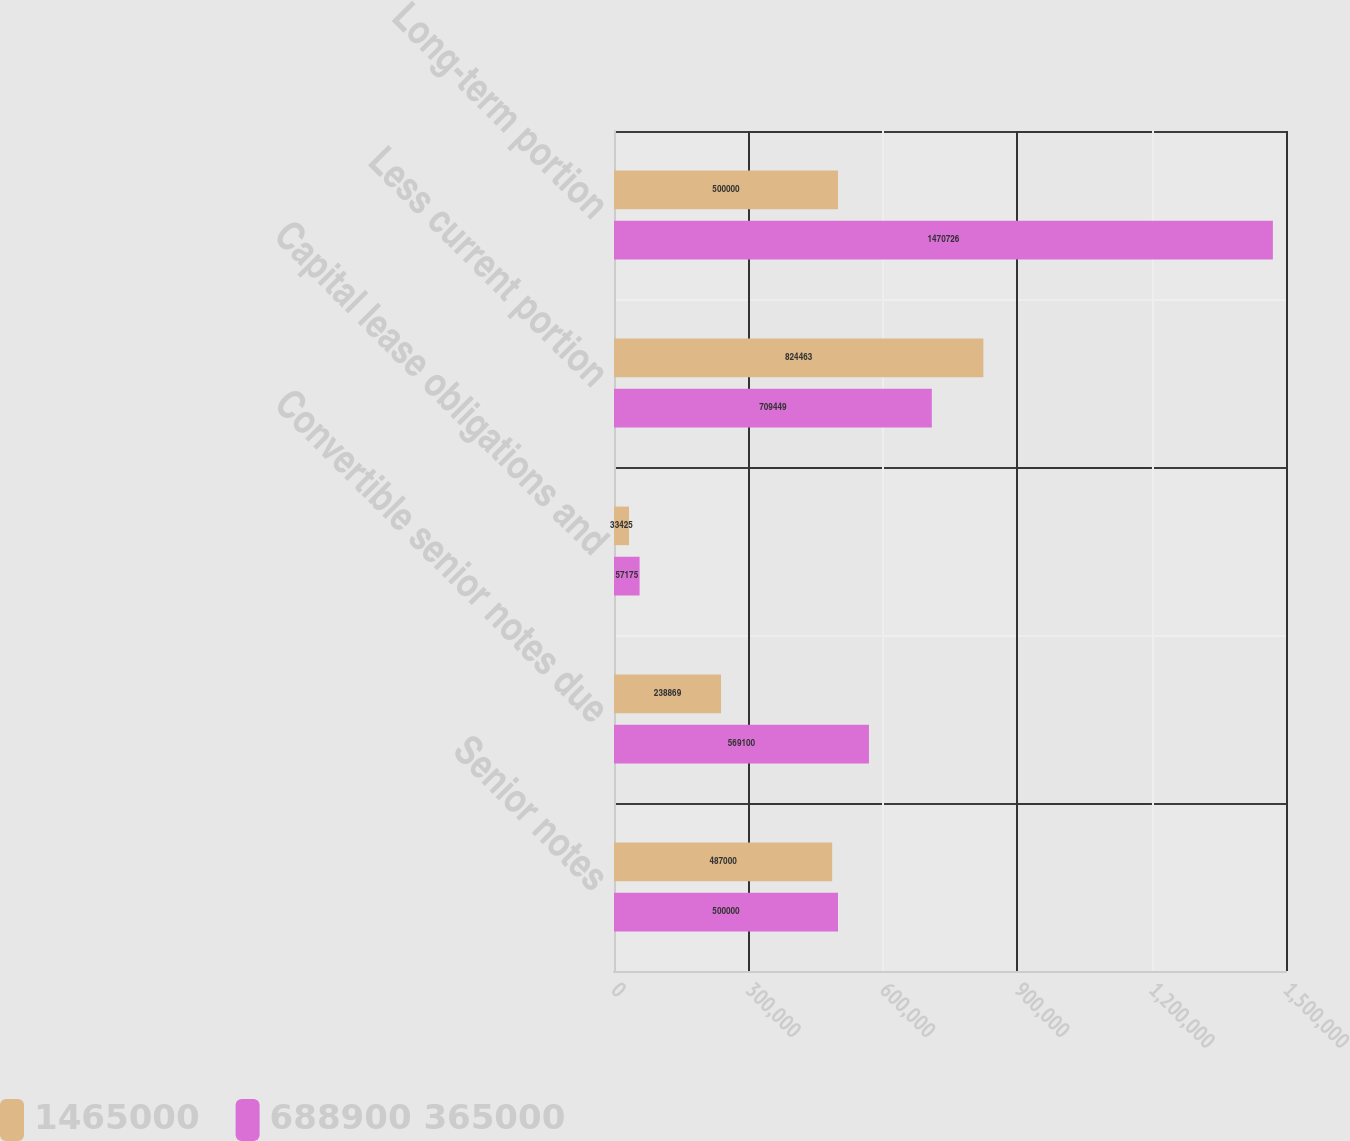Convert chart. <chart><loc_0><loc_0><loc_500><loc_500><stacked_bar_chart><ecel><fcel>Senior notes<fcel>Convertible senior notes due<fcel>Capital lease obligations and<fcel>Less current portion<fcel>Long-term portion<nl><fcel>1465000<fcel>487000<fcel>238869<fcel>33425<fcel>824463<fcel>500000<nl><fcel>688900 365000<fcel>500000<fcel>569100<fcel>57175<fcel>709449<fcel>1.47073e+06<nl></chart> 